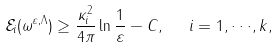<formula> <loc_0><loc_0><loc_500><loc_500>\mathcal { E } _ { i } ( \omega ^ { \varepsilon , \Lambda } ) \geq \frac { \kappa _ { i } ^ { 2 } } { 4 \pi } \ln \frac { 1 } { \varepsilon } - C , \ \ i = 1 , \cdot \cdot \cdot , k ,</formula> 